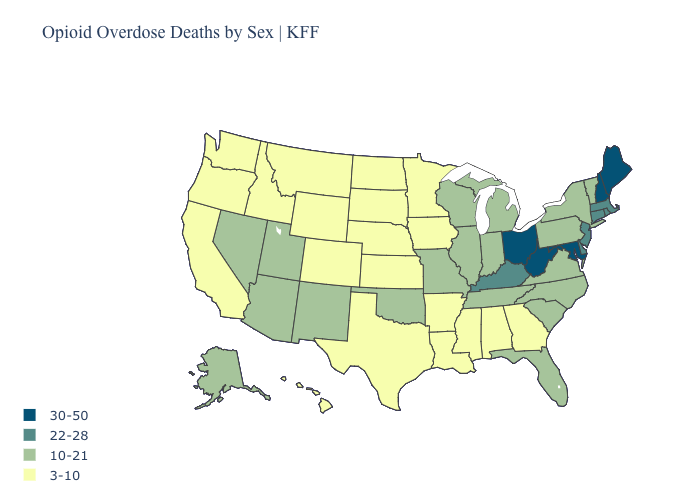What is the value of Idaho?
Give a very brief answer. 3-10. What is the lowest value in the USA?
Short answer required. 3-10. Among the states that border Wisconsin , which have the highest value?
Concise answer only. Illinois, Michigan. What is the highest value in the West ?
Concise answer only. 10-21. What is the value of Kansas?
Keep it brief. 3-10. Name the states that have a value in the range 10-21?
Quick response, please. Alaska, Arizona, Florida, Illinois, Indiana, Michigan, Missouri, Nevada, New Mexico, New York, North Carolina, Oklahoma, Pennsylvania, South Carolina, Tennessee, Utah, Vermont, Virginia, Wisconsin. Does the map have missing data?
Keep it brief. No. Does Missouri have the same value as Michigan?
Answer briefly. Yes. Name the states that have a value in the range 30-50?
Keep it brief. Maine, Maryland, New Hampshire, Ohio, West Virginia. What is the highest value in the South ?
Quick response, please. 30-50. Which states have the lowest value in the MidWest?
Concise answer only. Iowa, Kansas, Minnesota, Nebraska, North Dakota, South Dakota. Does Maryland have the same value as Maine?
Keep it brief. Yes. What is the lowest value in states that border Virginia?
Keep it brief. 10-21. Name the states that have a value in the range 30-50?
Quick response, please. Maine, Maryland, New Hampshire, Ohio, West Virginia. Does the map have missing data?
Be succinct. No. 